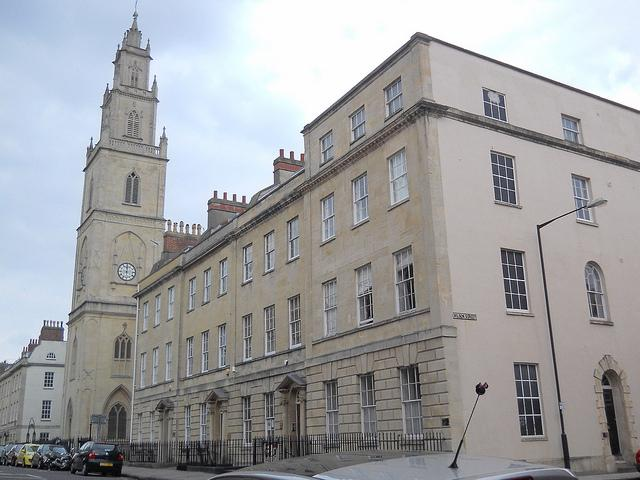What color are the chimney pieces on the top of the long rectangular house? Please explain your reasoning. red. The color is red. 